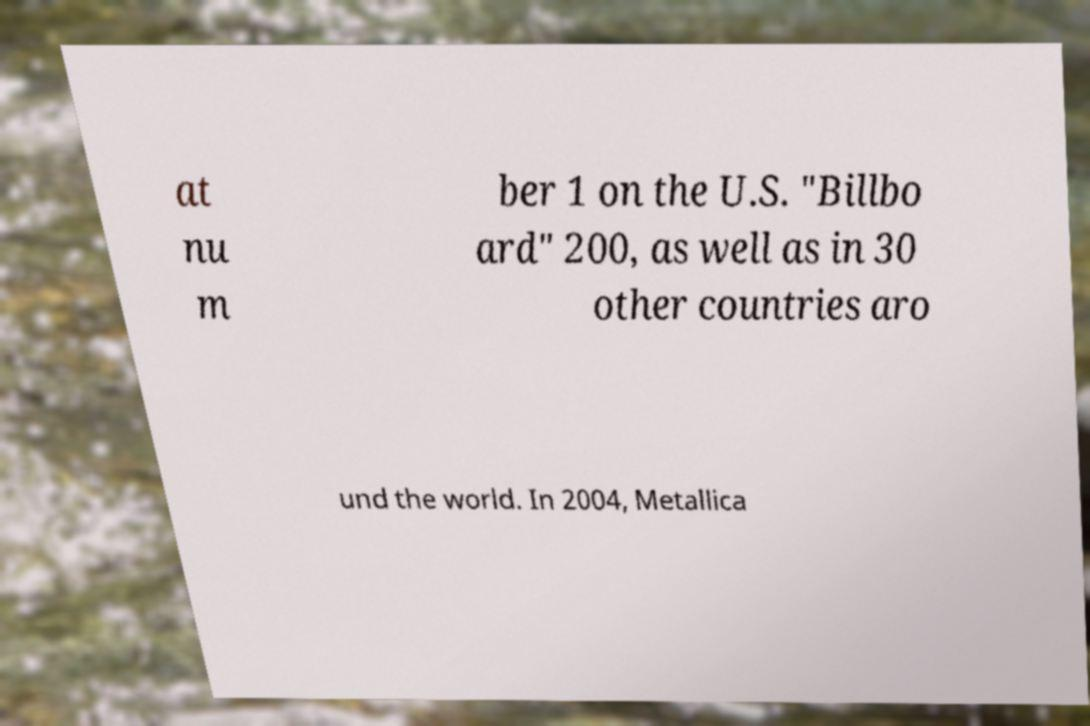Can you read and provide the text displayed in the image?This photo seems to have some interesting text. Can you extract and type it out for me? at nu m ber 1 on the U.S. "Billbo ard" 200, as well as in 30 other countries aro und the world. In 2004, Metallica 